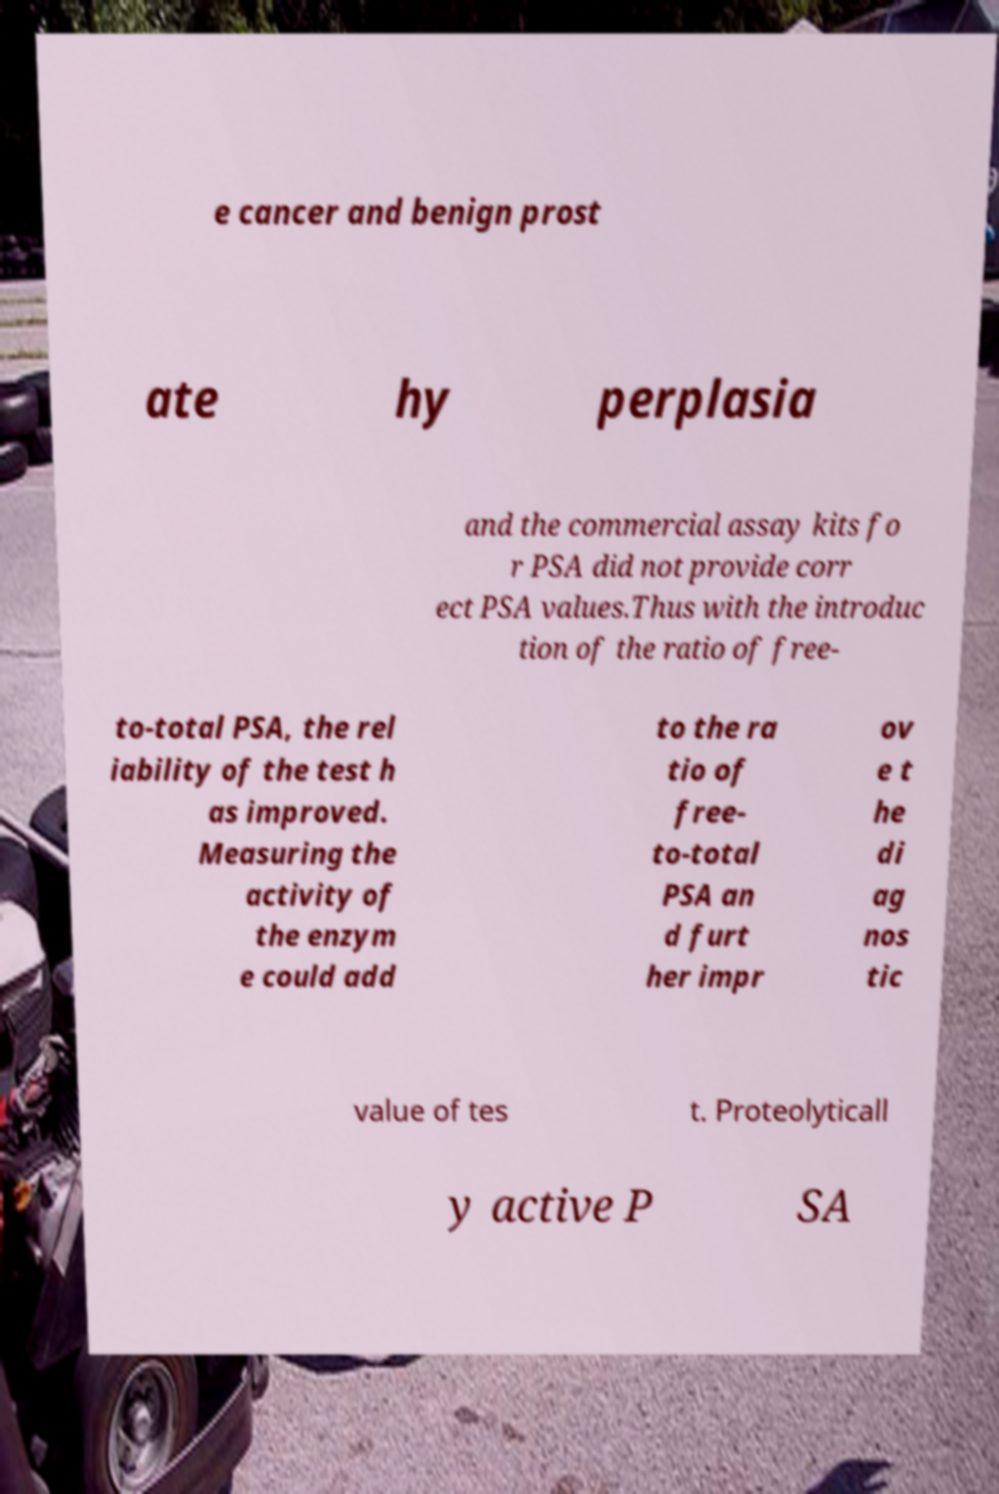Please identify and transcribe the text found in this image. e cancer and benign prost ate hy perplasia and the commercial assay kits fo r PSA did not provide corr ect PSA values.Thus with the introduc tion of the ratio of free- to-total PSA, the rel iability of the test h as improved. Measuring the activity of the enzym e could add to the ra tio of free- to-total PSA an d furt her impr ov e t he di ag nos tic value of tes t. Proteolyticall y active P SA 